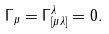Convert formula to latex. <formula><loc_0><loc_0><loc_500><loc_500>\Gamma _ { \mu } = \Gamma ^ { \lambda } _ { [ \mu \lambda ] } = 0 .</formula> 